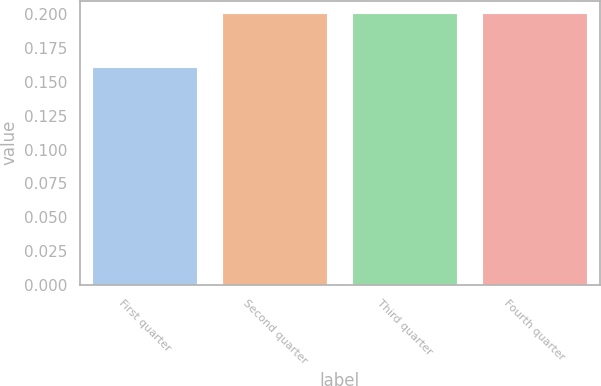Convert chart. <chart><loc_0><loc_0><loc_500><loc_500><bar_chart><fcel>First quarter<fcel>Second quarter<fcel>Third quarter<fcel>Fourth quarter<nl><fcel>0.16<fcel>0.2<fcel>0.2<fcel>0.2<nl></chart> 